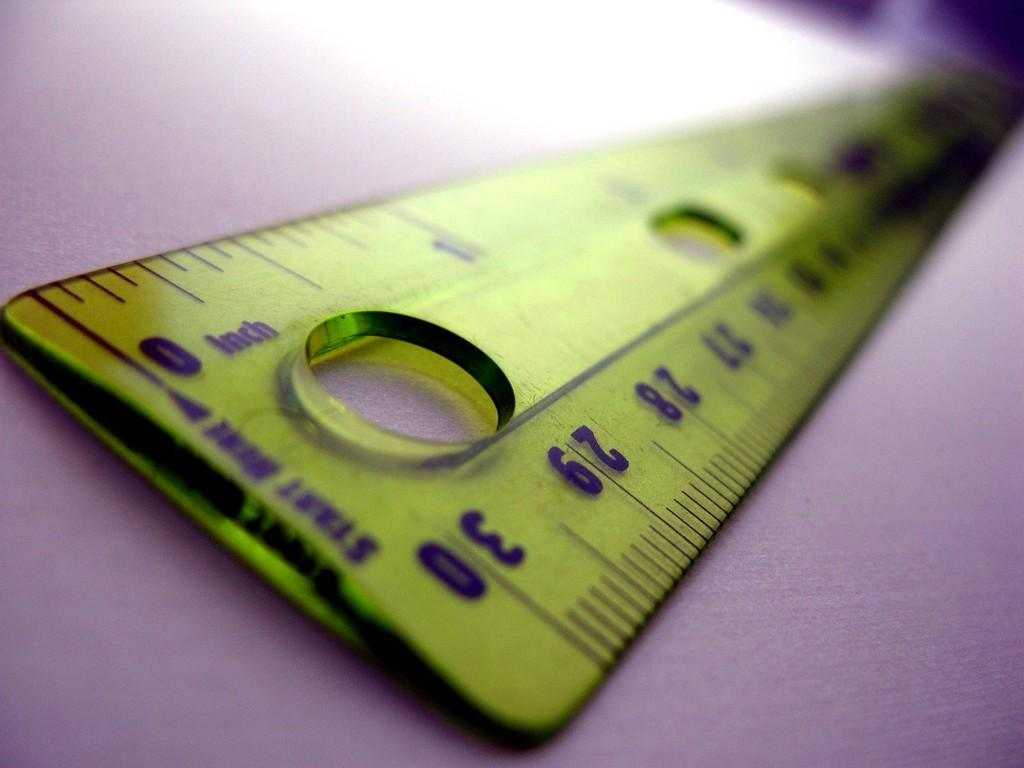<image>
Present a compact description of the photo's key features. Ruler that is thirty inches in length it is yellow and purple it is laying on a purple surface. 